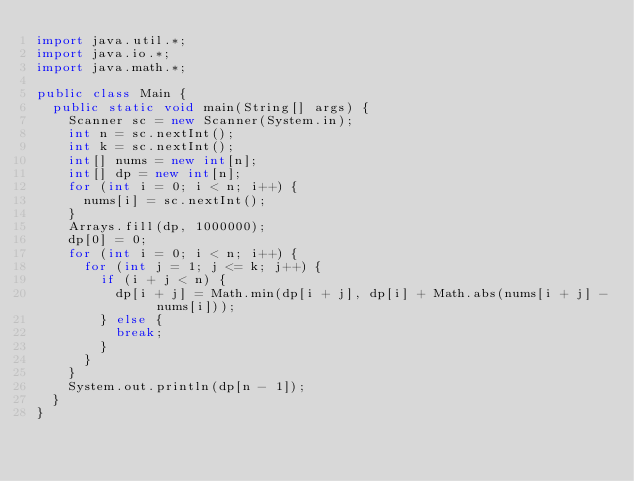<code> <loc_0><loc_0><loc_500><loc_500><_Java_>import java.util.*;
import java.io.*;
import java.math.*;

public class Main {
  public static void main(String[] args) {
    Scanner sc = new Scanner(System.in);
    int n = sc.nextInt();
    int k = sc.nextInt();
    int[] nums = new int[n];
    int[] dp = new int[n];
    for (int i = 0; i < n; i++) {
      nums[i] = sc.nextInt();
    }
    Arrays.fill(dp, 1000000);
    dp[0] = 0;
    for (int i = 0; i < n; i++) {
      for (int j = 1; j <= k; j++) {
        if (i + j < n) {
          dp[i + j] = Math.min(dp[i + j], dp[i] + Math.abs(nums[i + j] - nums[i]));
        } else {
          break;
        }
      }
    }
    System.out.println(dp[n - 1]);
  }
}</code> 